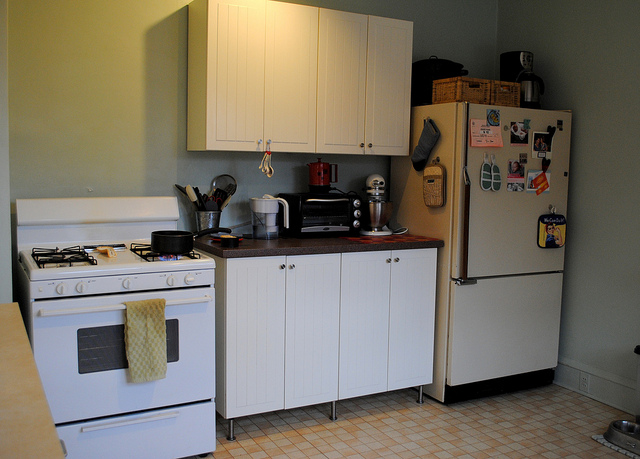<image>Is the kitchen new? I don't know if the kitchen is new. It's possible but most of the responses suggest it's not new. What beverage is on top of the refrigerator? It is uncertain what beverage is on top of the refrigerator. It could be coffee, beer, or wine. What pattern is on the oven mitt? I don't know what pattern is on the oven mitt, as it could be checked, striped, or dotted. Is the kitchen new? I don't know if the kitchen is new. It can be both new or not new. What beverage is on top of the refrigerator? I don't know what beverage is on top of the refrigerator. It can be either coffee or beer. What pattern is on the oven mitt? I don't know what pattern is on the oven mitt. It is not clear from the answers. 